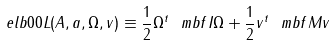<formula> <loc_0><loc_0><loc_500><loc_500>\ e l b { 0 0 } L ( A , a , \Omega , v ) \equiv \frac { 1 } { 2 } \Omega ^ { t } \ m b f I \Omega + \frac { 1 } { 2 } v ^ { t } \ m b f M v</formula> 